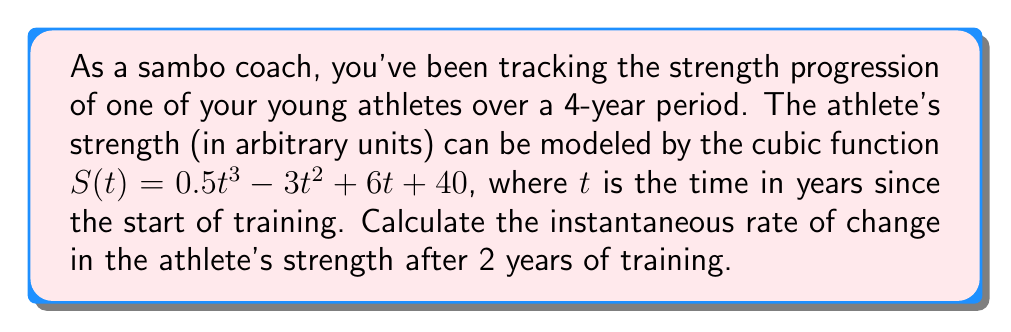Could you help me with this problem? To find the instantaneous rate of change in the athlete's strength after 2 years of training, we need to calculate the derivative of the given function $S(t)$ and evaluate it at $t=2$. Here's the step-by-step process:

1) The given function is $S(t) = 0.5t^3 - 3t^2 + 6t + 40$

2) To find the rate of change, we need to calculate $S'(t)$. Let's use the power rule of differentiation:
   
   $S'(t) = 1.5t^2 - 6t + 6$

3) Now, we need to evaluate $S'(2)$:
   
   $S'(2) = 1.5(2)^2 - 6(2) + 6$
   
   $= 1.5(4) - 12 + 6$
   
   $= 6 - 12 + 6$
   
   $= 0$

The instantaneous rate of change is the value of the derivative at the given point. In this case, it's 0 strength units per year.

This result indicates that after 2 years of training, the athlete's strength is momentarily neither increasing nor decreasing. In the context of athletic training, this could represent a plateau in strength gains, which is a common phenomenon in long-term athletic development.
Answer: 0 strength units per year 